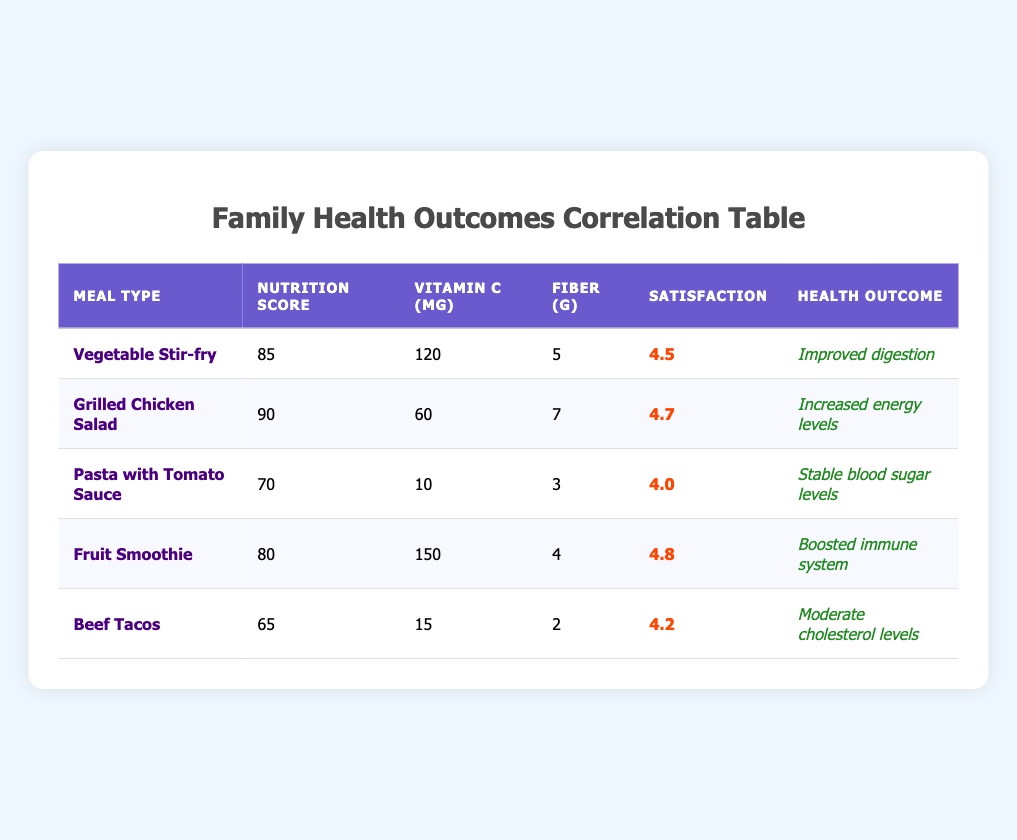What is the nutrition score of the Fruit Smoothie? The table shows that the Fruit Smoothie has a nutrition score listed as 80.
Answer: 80 Which meal has the highest satisfaction rating? Looking through the satisfaction ratings in the table, the Grilled Chicken Salad has the highest rating of 4.7.
Answer: Grilled Chicken Salad What is the average fiber content of the meals? To find the average fiber content, we add the fiber values (5 + 7 + 3 + 4 + 2 = 21) and divide by the number of meals (5). The average is 21/5 = 4.2.
Answer: 4.2 Is the Beef Tacos meal associated with improved digestion? According to the table, the Beef Tacos meal has a health outcome of moderate cholesterol levels, not improved digestion. Therefore, the answer is no.
Answer: No Which meal has both the highest vitamin C content and contributes to boosted immune system health? The Fruit Smoothie has the highest vitamin C content of 150 mg, and its associated health outcome is boosted immune system, fulfilling both criteria.
Answer: Fruit Smoothie What is the difference in nutrition score between the Grilled Chicken Salad and Beef Tacos? The nutrition score for Grilled Chicken Salad is 90, and for Beef Tacos, it is 65. The difference is calculated by subtracting: 90 - 65 = 25.
Answer: 25 Which meal types have satisfaction ratings of 4.5 or higher? By analyzing the ratings in the table, the meals that meet this criterion are Vegetable Stir-fry (4.5), Grilled Chicken Salad (4.7), Fruit Smoothie (4.8), and Beef Tacos (4.2). Thus, the meals with ratings of 4.5 or higher are Vegetable Stir-fry, Grilled Chicken Salad and Fruit Smoothie.
Answer: Vegetable Stir-fry, Grilled Chicken Salad, Fruit Smoothie Does any meal type have a health outcome related to stable blood sugar levels? Yes, the Pasta with Tomato Sauce specifically states that it is associated with stable blood sugar levels, making the answer yes.
Answer: Yes What meal has the lowest fiber content and what is its fiber amount? Reviewing the fiber data in the table, the meal with the lowest fiber content is Beef Tacos, which contains 2 grams of fiber.
Answer: Beef Tacos, 2 grams 